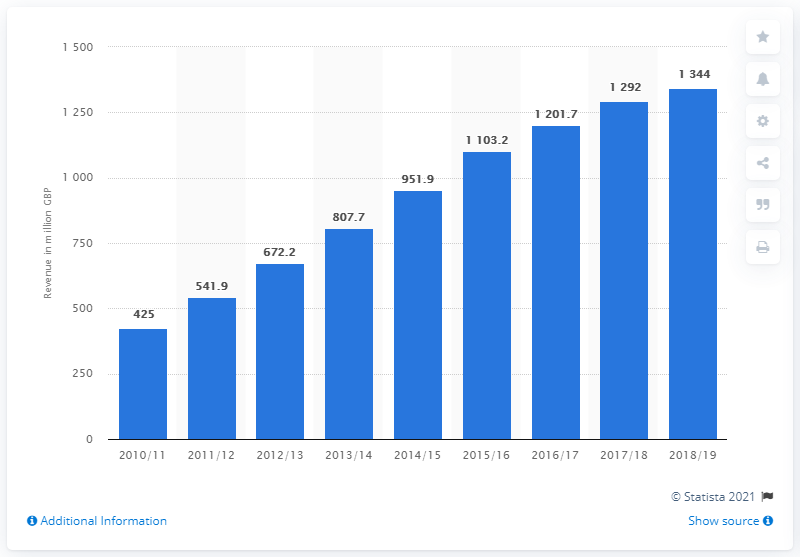Mention a couple of crucial points in this snapshot. In the previous year, the revenue for Costa Coffee was 1292. 